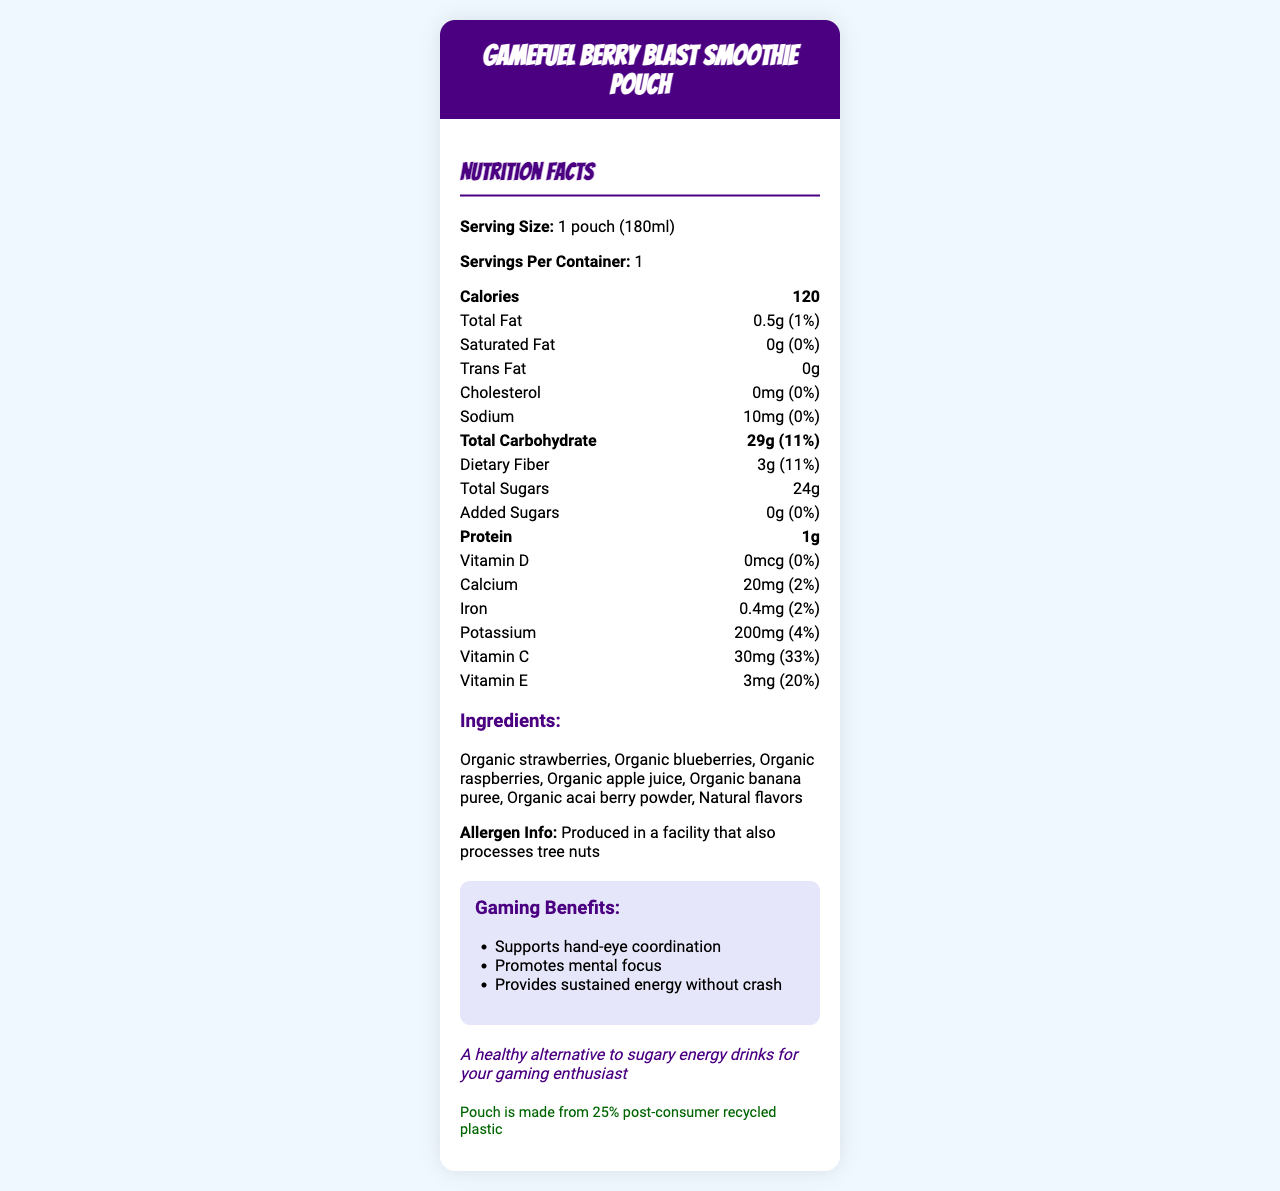what is the serving size of the GameFuel Berry Blast Smoothie Pouch? The serving size is listed under the "Serving Size" section of the Nutrition Facts.
Answer: 1 pouch (180ml) how many calories are there per pouch? The calorie count is prominently displayed in a bold font under the "Calories" section of the Nutrition Facts.
Answer: 120 what is the total amount of sugars in the smoothie pouch? The amount of "Total Sugars" is shown directly under the "Total Carbohydrate" section.
Answer: 24g what ingredient is listed first in the ingredients section? Ingredients are listed in the section titled "Ingredients," and the first one mentioned is "Organic strawberries."
Answer: Organic strawberries what is the daily value percentage of Vitamin C in the smoothie pouch? The daily value percentage for Vitamin C is listed as 33% next to the quantity (30 mg).
Answer: 33% which of the following does the smoothie contain? A. Artificial colors B. Tree nuts C. Antioxidants D. Preservatives The document states “Rich in antioxidants” under "Additional Info". There are no artificial colors or preservatives as mentioned, and it only indicates the facility also processes tree nuts, not that the smoothie contains them.
Answer: C. Antioxidants what is the amount of protein per serving? The amount of protein is listed in the Nutrition Facts under the "Protein" section.
Answer: 1g how much iron is in the smoothie? The amount of iron is listed in the Nutrition Facts, showing 0.4mg.
Answer: 0.4mg is the smoothie carbohyrate-free? There is a section labeled "Total Carbohydrate," which shows an amount of 29g.
Answer: No this smoothie is pediatrician approved for which group? It's stated under "Additional Info" that the smoothie is "Pediatrician approved for growing gamers."
Answer: growing gamers Which of the following gaming benefits does the smoothie provide? i. Supports hand-eye coordination ii. Promotes mental focus iii. Provides sustained energy without crash iv. Builds muscle mass The "Gaming Benefits" section lists the mentioned benefits, except for building muscle mass.
Answer: i. Supports hand-eye coordination ii. Promotes mental focus iii. Provides sustained energy without crash Can this document tell us how long the smoothie lasts before expiring? There is no information provided in the document regarding the expiration date or shelf life.
Answer: Not enough information describe the overall contents of the document. The document focuses on delivering detailed nutritional information about a fruit smoothie designed for on-the-go consumption and highlights its health benefits and suitability for gamers.
Answer: The document presents the Nutrition Facts for the GameFuel Berry Blast Smoothie Pouch, detailing serving size, caloric content, fat, carbohydrates, sugars, protein, vitamins, and minerals. It also lists organic ingredients, mentions allergen information, gaming-related benefits, and provides a sustainability note about the packaging. The product is noted as pediatrician approved for children who game. 